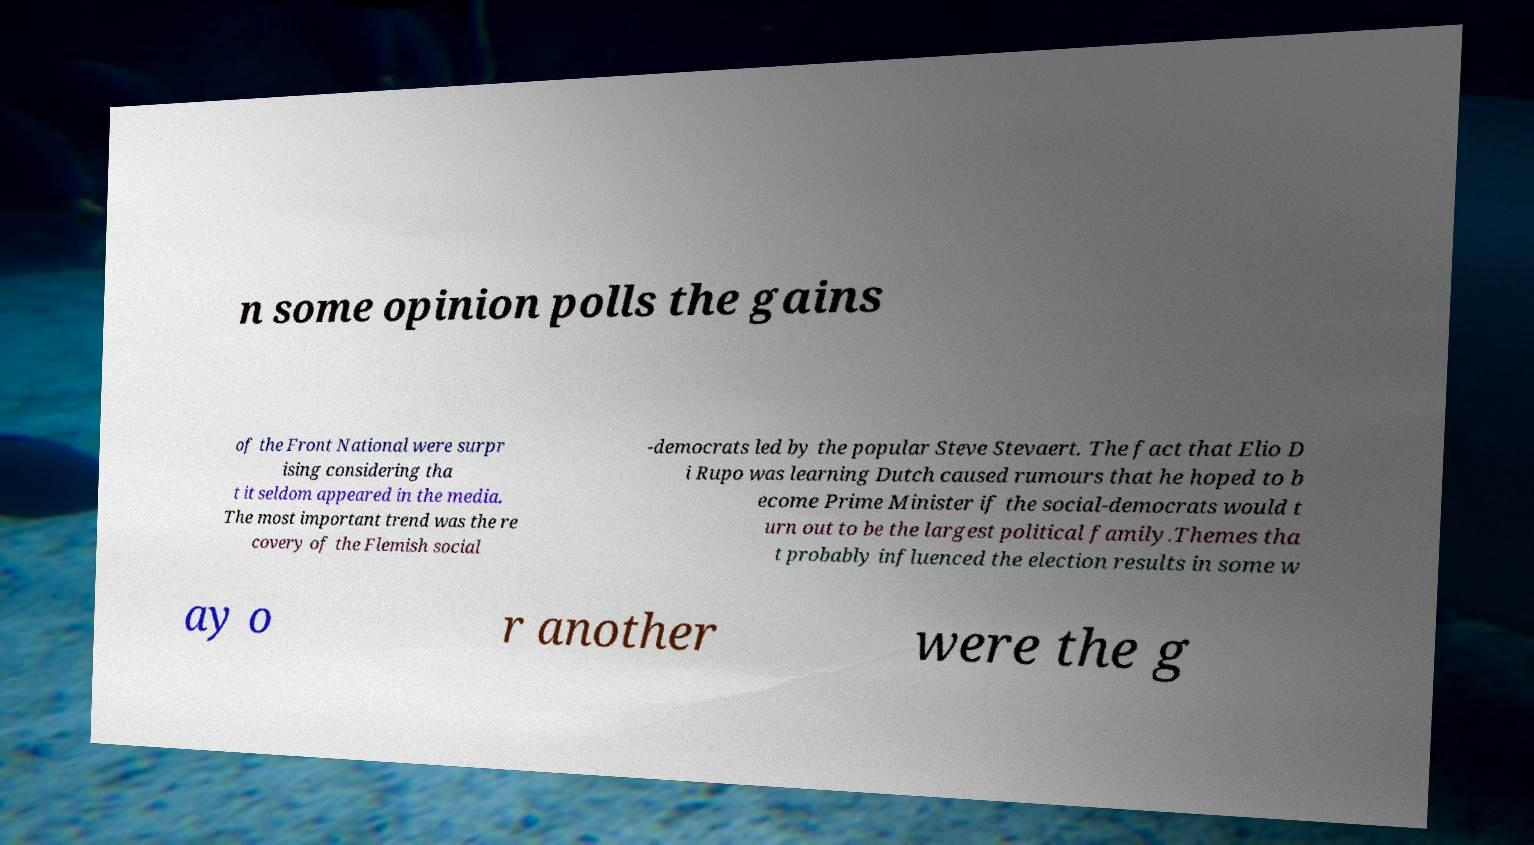Please read and relay the text visible in this image. What does it say? n some opinion polls the gains of the Front National were surpr ising considering tha t it seldom appeared in the media. The most important trend was the re covery of the Flemish social -democrats led by the popular Steve Stevaert. The fact that Elio D i Rupo was learning Dutch caused rumours that he hoped to b ecome Prime Minister if the social-democrats would t urn out to be the largest political family.Themes tha t probably influenced the election results in some w ay o r another were the g 